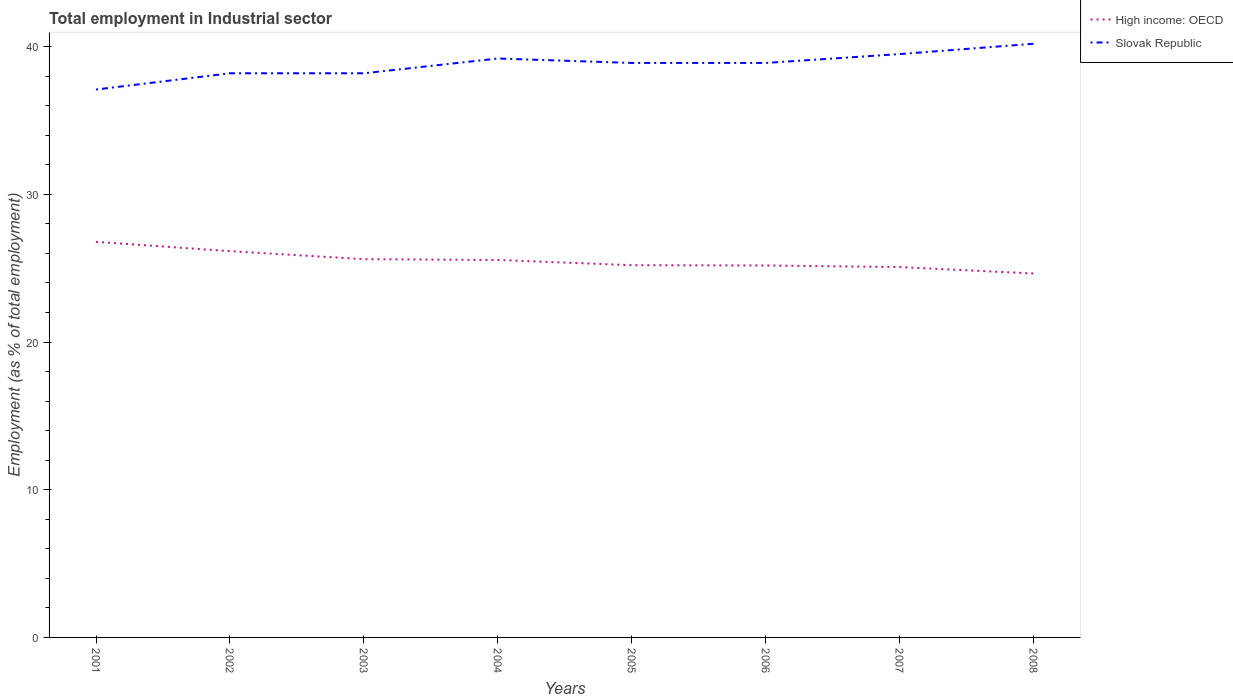Does the line corresponding to High income: OECD intersect with the line corresponding to Slovak Republic?
Provide a succinct answer. No. Across all years, what is the maximum employment in industrial sector in Slovak Republic?
Make the answer very short. 37.1. What is the total employment in industrial sector in High income: OECD in the graph?
Your answer should be very brief. 1.17. What is the difference between the highest and the second highest employment in industrial sector in Slovak Republic?
Keep it short and to the point. 3.1. What is the difference between two consecutive major ticks on the Y-axis?
Your answer should be compact. 10. Does the graph contain any zero values?
Provide a short and direct response. No. How many legend labels are there?
Provide a short and direct response. 2. What is the title of the graph?
Provide a short and direct response. Total employment in Industrial sector. What is the label or title of the X-axis?
Offer a very short reply. Years. What is the label or title of the Y-axis?
Make the answer very short. Employment (as % of total employment). What is the Employment (as % of total employment) of High income: OECD in 2001?
Ensure brevity in your answer.  26.78. What is the Employment (as % of total employment) of Slovak Republic in 2001?
Your response must be concise. 37.1. What is the Employment (as % of total employment) of High income: OECD in 2002?
Provide a short and direct response. 26.16. What is the Employment (as % of total employment) of Slovak Republic in 2002?
Provide a succinct answer. 38.2. What is the Employment (as % of total employment) in High income: OECD in 2003?
Your response must be concise. 25.61. What is the Employment (as % of total employment) in Slovak Republic in 2003?
Your response must be concise. 38.2. What is the Employment (as % of total employment) of High income: OECD in 2004?
Your response must be concise. 25.56. What is the Employment (as % of total employment) in Slovak Republic in 2004?
Ensure brevity in your answer.  39.2. What is the Employment (as % of total employment) in High income: OECD in 2005?
Offer a very short reply. 25.2. What is the Employment (as % of total employment) of Slovak Republic in 2005?
Provide a succinct answer. 38.9. What is the Employment (as % of total employment) of High income: OECD in 2006?
Make the answer very short. 25.19. What is the Employment (as % of total employment) in Slovak Republic in 2006?
Offer a very short reply. 38.9. What is the Employment (as % of total employment) in High income: OECD in 2007?
Give a very brief answer. 25.08. What is the Employment (as % of total employment) in Slovak Republic in 2007?
Provide a succinct answer. 39.5. What is the Employment (as % of total employment) of High income: OECD in 2008?
Ensure brevity in your answer.  24.64. What is the Employment (as % of total employment) of Slovak Republic in 2008?
Your response must be concise. 40.2. Across all years, what is the maximum Employment (as % of total employment) in High income: OECD?
Your response must be concise. 26.78. Across all years, what is the maximum Employment (as % of total employment) of Slovak Republic?
Your answer should be compact. 40.2. Across all years, what is the minimum Employment (as % of total employment) in High income: OECD?
Offer a very short reply. 24.64. Across all years, what is the minimum Employment (as % of total employment) of Slovak Republic?
Give a very brief answer. 37.1. What is the total Employment (as % of total employment) in High income: OECD in the graph?
Provide a succinct answer. 204.22. What is the total Employment (as % of total employment) in Slovak Republic in the graph?
Your answer should be compact. 310.2. What is the difference between the Employment (as % of total employment) of High income: OECD in 2001 and that in 2002?
Offer a terse response. 0.63. What is the difference between the Employment (as % of total employment) in Slovak Republic in 2001 and that in 2002?
Ensure brevity in your answer.  -1.1. What is the difference between the Employment (as % of total employment) in High income: OECD in 2001 and that in 2003?
Your answer should be very brief. 1.17. What is the difference between the Employment (as % of total employment) in Slovak Republic in 2001 and that in 2003?
Give a very brief answer. -1.1. What is the difference between the Employment (as % of total employment) in High income: OECD in 2001 and that in 2004?
Your response must be concise. 1.23. What is the difference between the Employment (as % of total employment) in Slovak Republic in 2001 and that in 2004?
Ensure brevity in your answer.  -2.1. What is the difference between the Employment (as % of total employment) of High income: OECD in 2001 and that in 2005?
Give a very brief answer. 1.58. What is the difference between the Employment (as % of total employment) in Slovak Republic in 2001 and that in 2005?
Make the answer very short. -1.8. What is the difference between the Employment (as % of total employment) in High income: OECD in 2001 and that in 2006?
Offer a very short reply. 1.6. What is the difference between the Employment (as % of total employment) of Slovak Republic in 2001 and that in 2006?
Your answer should be very brief. -1.8. What is the difference between the Employment (as % of total employment) of High income: OECD in 2001 and that in 2007?
Offer a terse response. 1.71. What is the difference between the Employment (as % of total employment) in High income: OECD in 2001 and that in 2008?
Give a very brief answer. 2.14. What is the difference between the Employment (as % of total employment) of High income: OECD in 2002 and that in 2003?
Ensure brevity in your answer.  0.54. What is the difference between the Employment (as % of total employment) of Slovak Republic in 2002 and that in 2003?
Make the answer very short. 0. What is the difference between the Employment (as % of total employment) in High income: OECD in 2002 and that in 2004?
Provide a succinct answer. 0.6. What is the difference between the Employment (as % of total employment) in High income: OECD in 2002 and that in 2005?
Make the answer very short. 0.95. What is the difference between the Employment (as % of total employment) of High income: OECD in 2002 and that in 2006?
Keep it short and to the point. 0.97. What is the difference between the Employment (as % of total employment) of Slovak Republic in 2002 and that in 2006?
Offer a terse response. -0.7. What is the difference between the Employment (as % of total employment) in High income: OECD in 2002 and that in 2007?
Your response must be concise. 1.08. What is the difference between the Employment (as % of total employment) of High income: OECD in 2002 and that in 2008?
Your response must be concise. 1.51. What is the difference between the Employment (as % of total employment) in Slovak Republic in 2002 and that in 2008?
Make the answer very short. -2. What is the difference between the Employment (as % of total employment) of High income: OECD in 2003 and that in 2004?
Your answer should be very brief. 0.06. What is the difference between the Employment (as % of total employment) in High income: OECD in 2003 and that in 2005?
Provide a short and direct response. 0.41. What is the difference between the Employment (as % of total employment) of Slovak Republic in 2003 and that in 2005?
Keep it short and to the point. -0.7. What is the difference between the Employment (as % of total employment) of High income: OECD in 2003 and that in 2006?
Provide a succinct answer. 0.43. What is the difference between the Employment (as % of total employment) in Slovak Republic in 2003 and that in 2006?
Provide a succinct answer. -0.7. What is the difference between the Employment (as % of total employment) of High income: OECD in 2003 and that in 2007?
Make the answer very short. 0.54. What is the difference between the Employment (as % of total employment) of High income: OECD in 2003 and that in 2008?
Your response must be concise. 0.97. What is the difference between the Employment (as % of total employment) in Slovak Republic in 2003 and that in 2008?
Offer a very short reply. -2. What is the difference between the Employment (as % of total employment) of High income: OECD in 2004 and that in 2005?
Your answer should be compact. 0.35. What is the difference between the Employment (as % of total employment) of High income: OECD in 2004 and that in 2006?
Keep it short and to the point. 0.37. What is the difference between the Employment (as % of total employment) of High income: OECD in 2004 and that in 2007?
Provide a succinct answer. 0.48. What is the difference between the Employment (as % of total employment) of High income: OECD in 2004 and that in 2008?
Offer a terse response. 0.92. What is the difference between the Employment (as % of total employment) in Slovak Republic in 2004 and that in 2008?
Your response must be concise. -1. What is the difference between the Employment (as % of total employment) of High income: OECD in 2005 and that in 2006?
Give a very brief answer. 0.02. What is the difference between the Employment (as % of total employment) in Slovak Republic in 2005 and that in 2006?
Keep it short and to the point. 0. What is the difference between the Employment (as % of total employment) in High income: OECD in 2005 and that in 2007?
Offer a very short reply. 0.13. What is the difference between the Employment (as % of total employment) of High income: OECD in 2005 and that in 2008?
Your answer should be compact. 0.56. What is the difference between the Employment (as % of total employment) in Slovak Republic in 2005 and that in 2008?
Keep it short and to the point. -1.3. What is the difference between the Employment (as % of total employment) in High income: OECD in 2006 and that in 2007?
Provide a short and direct response. 0.11. What is the difference between the Employment (as % of total employment) in High income: OECD in 2006 and that in 2008?
Offer a very short reply. 0.54. What is the difference between the Employment (as % of total employment) in High income: OECD in 2007 and that in 2008?
Your answer should be compact. 0.44. What is the difference between the Employment (as % of total employment) in High income: OECD in 2001 and the Employment (as % of total employment) in Slovak Republic in 2002?
Keep it short and to the point. -11.42. What is the difference between the Employment (as % of total employment) in High income: OECD in 2001 and the Employment (as % of total employment) in Slovak Republic in 2003?
Offer a very short reply. -11.42. What is the difference between the Employment (as % of total employment) of High income: OECD in 2001 and the Employment (as % of total employment) of Slovak Republic in 2004?
Keep it short and to the point. -12.42. What is the difference between the Employment (as % of total employment) in High income: OECD in 2001 and the Employment (as % of total employment) in Slovak Republic in 2005?
Provide a succinct answer. -12.12. What is the difference between the Employment (as % of total employment) in High income: OECD in 2001 and the Employment (as % of total employment) in Slovak Republic in 2006?
Your answer should be compact. -12.12. What is the difference between the Employment (as % of total employment) of High income: OECD in 2001 and the Employment (as % of total employment) of Slovak Republic in 2007?
Offer a terse response. -12.72. What is the difference between the Employment (as % of total employment) of High income: OECD in 2001 and the Employment (as % of total employment) of Slovak Republic in 2008?
Your response must be concise. -13.42. What is the difference between the Employment (as % of total employment) of High income: OECD in 2002 and the Employment (as % of total employment) of Slovak Republic in 2003?
Keep it short and to the point. -12.04. What is the difference between the Employment (as % of total employment) of High income: OECD in 2002 and the Employment (as % of total employment) of Slovak Republic in 2004?
Give a very brief answer. -13.04. What is the difference between the Employment (as % of total employment) of High income: OECD in 2002 and the Employment (as % of total employment) of Slovak Republic in 2005?
Your answer should be compact. -12.74. What is the difference between the Employment (as % of total employment) in High income: OECD in 2002 and the Employment (as % of total employment) in Slovak Republic in 2006?
Make the answer very short. -12.74. What is the difference between the Employment (as % of total employment) of High income: OECD in 2002 and the Employment (as % of total employment) of Slovak Republic in 2007?
Your answer should be compact. -13.35. What is the difference between the Employment (as % of total employment) in High income: OECD in 2002 and the Employment (as % of total employment) in Slovak Republic in 2008?
Give a very brief answer. -14.04. What is the difference between the Employment (as % of total employment) of High income: OECD in 2003 and the Employment (as % of total employment) of Slovak Republic in 2004?
Ensure brevity in your answer.  -13.59. What is the difference between the Employment (as % of total employment) in High income: OECD in 2003 and the Employment (as % of total employment) in Slovak Republic in 2005?
Ensure brevity in your answer.  -13.29. What is the difference between the Employment (as % of total employment) of High income: OECD in 2003 and the Employment (as % of total employment) of Slovak Republic in 2006?
Provide a short and direct response. -13.29. What is the difference between the Employment (as % of total employment) in High income: OECD in 2003 and the Employment (as % of total employment) in Slovak Republic in 2007?
Your answer should be very brief. -13.89. What is the difference between the Employment (as % of total employment) of High income: OECD in 2003 and the Employment (as % of total employment) of Slovak Republic in 2008?
Offer a very short reply. -14.59. What is the difference between the Employment (as % of total employment) in High income: OECD in 2004 and the Employment (as % of total employment) in Slovak Republic in 2005?
Provide a succinct answer. -13.34. What is the difference between the Employment (as % of total employment) of High income: OECD in 2004 and the Employment (as % of total employment) of Slovak Republic in 2006?
Offer a very short reply. -13.34. What is the difference between the Employment (as % of total employment) of High income: OECD in 2004 and the Employment (as % of total employment) of Slovak Republic in 2007?
Make the answer very short. -13.94. What is the difference between the Employment (as % of total employment) of High income: OECD in 2004 and the Employment (as % of total employment) of Slovak Republic in 2008?
Your answer should be compact. -14.64. What is the difference between the Employment (as % of total employment) in High income: OECD in 2005 and the Employment (as % of total employment) in Slovak Republic in 2006?
Your answer should be very brief. -13.7. What is the difference between the Employment (as % of total employment) of High income: OECD in 2005 and the Employment (as % of total employment) of Slovak Republic in 2007?
Make the answer very short. -14.3. What is the difference between the Employment (as % of total employment) in High income: OECD in 2005 and the Employment (as % of total employment) in Slovak Republic in 2008?
Ensure brevity in your answer.  -15. What is the difference between the Employment (as % of total employment) of High income: OECD in 2006 and the Employment (as % of total employment) of Slovak Republic in 2007?
Make the answer very short. -14.31. What is the difference between the Employment (as % of total employment) of High income: OECD in 2006 and the Employment (as % of total employment) of Slovak Republic in 2008?
Your answer should be compact. -15.01. What is the difference between the Employment (as % of total employment) in High income: OECD in 2007 and the Employment (as % of total employment) in Slovak Republic in 2008?
Make the answer very short. -15.12. What is the average Employment (as % of total employment) of High income: OECD per year?
Make the answer very short. 25.53. What is the average Employment (as % of total employment) in Slovak Republic per year?
Make the answer very short. 38.77. In the year 2001, what is the difference between the Employment (as % of total employment) in High income: OECD and Employment (as % of total employment) in Slovak Republic?
Ensure brevity in your answer.  -10.32. In the year 2002, what is the difference between the Employment (as % of total employment) in High income: OECD and Employment (as % of total employment) in Slovak Republic?
Offer a terse response. -12.04. In the year 2003, what is the difference between the Employment (as % of total employment) in High income: OECD and Employment (as % of total employment) in Slovak Republic?
Give a very brief answer. -12.59. In the year 2004, what is the difference between the Employment (as % of total employment) of High income: OECD and Employment (as % of total employment) of Slovak Republic?
Offer a terse response. -13.64. In the year 2005, what is the difference between the Employment (as % of total employment) in High income: OECD and Employment (as % of total employment) in Slovak Republic?
Offer a terse response. -13.7. In the year 2006, what is the difference between the Employment (as % of total employment) in High income: OECD and Employment (as % of total employment) in Slovak Republic?
Offer a terse response. -13.71. In the year 2007, what is the difference between the Employment (as % of total employment) in High income: OECD and Employment (as % of total employment) in Slovak Republic?
Make the answer very short. -14.42. In the year 2008, what is the difference between the Employment (as % of total employment) of High income: OECD and Employment (as % of total employment) of Slovak Republic?
Provide a short and direct response. -15.56. What is the ratio of the Employment (as % of total employment) of High income: OECD in 2001 to that in 2002?
Offer a terse response. 1.02. What is the ratio of the Employment (as % of total employment) of Slovak Republic in 2001 to that in 2002?
Keep it short and to the point. 0.97. What is the ratio of the Employment (as % of total employment) of High income: OECD in 2001 to that in 2003?
Your response must be concise. 1.05. What is the ratio of the Employment (as % of total employment) of Slovak Republic in 2001 to that in 2003?
Your answer should be very brief. 0.97. What is the ratio of the Employment (as % of total employment) of High income: OECD in 2001 to that in 2004?
Offer a terse response. 1.05. What is the ratio of the Employment (as % of total employment) of Slovak Republic in 2001 to that in 2004?
Keep it short and to the point. 0.95. What is the ratio of the Employment (as % of total employment) in High income: OECD in 2001 to that in 2005?
Make the answer very short. 1.06. What is the ratio of the Employment (as % of total employment) of Slovak Republic in 2001 to that in 2005?
Your answer should be compact. 0.95. What is the ratio of the Employment (as % of total employment) in High income: OECD in 2001 to that in 2006?
Provide a succinct answer. 1.06. What is the ratio of the Employment (as % of total employment) of Slovak Republic in 2001 to that in 2006?
Your response must be concise. 0.95. What is the ratio of the Employment (as % of total employment) of High income: OECD in 2001 to that in 2007?
Make the answer very short. 1.07. What is the ratio of the Employment (as % of total employment) in Slovak Republic in 2001 to that in 2007?
Ensure brevity in your answer.  0.94. What is the ratio of the Employment (as % of total employment) of High income: OECD in 2001 to that in 2008?
Ensure brevity in your answer.  1.09. What is the ratio of the Employment (as % of total employment) of Slovak Republic in 2001 to that in 2008?
Provide a succinct answer. 0.92. What is the ratio of the Employment (as % of total employment) in High income: OECD in 2002 to that in 2003?
Make the answer very short. 1.02. What is the ratio of the Employment (as % of total employment) in High income: OECD in 2002 to that in 2004?
Keep it short and to the point. 1.02. What is the ratio of the Employment (as % of total employment) in Slovak Republic in 2002 to that in 2004?
Provide a short and direct response. 0.97. What is the ratio of the Employment (as % of total employment) of High income: OECD in 2002 to that in 2005?
Provide a short and direct response. 1.04. What is the ratio of the Employment (as % of total employment) of Slovak Republic in 2002 to that in 2005?
Ensure brevity in your answer.  0.98. What is the ratio of the Employment (as % of total employment) in High income: OECD in 2002 to that in 2006?
Keep it short and to the point. 1.04. What is the ratio of the Employment (as % of total employment) in Slovak Republic in 2002 to that in 2006?
Give a very brief answer. 0.98. What is the ratio of the Employment (as % of total employment) in High income: OECD in 2002 to that in 2007?
Your response must be concise. 1.04. What is the ratio of the Employment (as % of total employment) of Slovak Republic in 2002 to that in 2007?
Your response must be concise. 0.97. What is the ratio of the Employment (as % of total employment) of High income: OECD in 2002 to that in 2008?
Provide a succinct answer. 1.06. What is the ratio of the Employment (as % of total employment) of Slovak Republic in 2002 to that in 2008?
Offer a very short reply. 0.95. What is the ratio of the Employment (as % of total employment) of Slovak Republic in 2003 to that in 2004?
Make the answer very short. 0.97. What is the ratio of the Employment (as % of total employment) in High income: OECD in 2003 to that in 2005?
Offer a terse response. 1.02. What is the ratio of the Employment (as % of total employment) in Slovak Republic in 2003 to that in 2006?
Your answer should be very brief. 0.98. What is the ratio of the Employment (as % of total employment) in High income: OECD in 2003 to that in 2007?
Your response must be concise. 1.02. What is the ratio of the Employment (as % of total employment) of Slovak Republic in 2003 to that in 2007?
Give a very brief answer. 0.97. What is the ratio of the Employment (as % of total employment) in High income: OECD in 2003 to that in 2008?
Make the answer very short. 1.04. What is the ratio of the Employment (as % of total employment) of Slovak Republic in 2003 to that in 2008?
Your response must be concise. 0.95. What is the ratio of the Employment (as % of total employment) of Slovak Republic in 2004 to that in 2005?
Your answer should be compact. 1.01. What is the ratio of the Employment (as % of total employment) of High income: OECD in 2004 to that in 2006?
Ensure brevity in your answer.  1.01. What is the ratio of the Employment (as % of total employment) in Slovak Republic in 2004 to that in 2006?
Your answer should be very brief. 1.01. What is the ratio of the Employment (as % of total employment) of High income: OECD in 2004 to that in 2007?
Make the answer very short. 1.02. What is the ratio of the Employment (as % of total employment) of High income: OECD in 2004 to that in 2008?
Make the answer very short. 1.04. What is the ratio of the Employment (as % of total employment) of Slovak Republic in 2004 to that in 2008?
Your answer should be very brief. 0.98. What is the ratio of the Employment (as % of total employment) in High income: OECD in 2005 to that in 2006?
Provide a short and direct response. 1. What is the ratio of the Employment (as % of total employment) of Slovak Republic in 2005 to that in 2006?
Your answer should be compact. 1. What is the ratio of the Employment (as % of total employment) of High income: OECD in 2005 to that in 2008?
Your answer should be very brief. 1.02. What is the ratio of the Employment (as % of total employment) in High income: OECD in 2006 to that in 2007?
Provide a short and direct response. 1. What is the ratio of the Employment (as % of total employment) of Slovak Republic in 2006 to that in 2007?
Give a very brief answer. 0.98. What is the ratio of the Employment (as % of total employment) in High income: OECD in 2006 to that in 2008?
Keep it short and to the point. 1.02. What is the ratio of the Employment (as % of total employment) in Slovak Republic in 2006 to that in 2008?
Your answer should be compact. 0.97. What is the ratio of the Employment (as % of total employment) in High income: OECD in 2007 to that in 2008?
Offer a terse response. 1.02. What is the ratio of the Employment (as % of total employment) of Slovak Republic in 2007 to that in 2008?
Your answer should be compact. 0.98. What is the difference between the highest and the second highest Employment (as % of total employment) in High income: OECD?
Offer a very short reply. 0.63. What is the difference between the highest and the lowest Employment (as % of total employment) of High income: OECD?
Your answer should be compact. 2.14. 